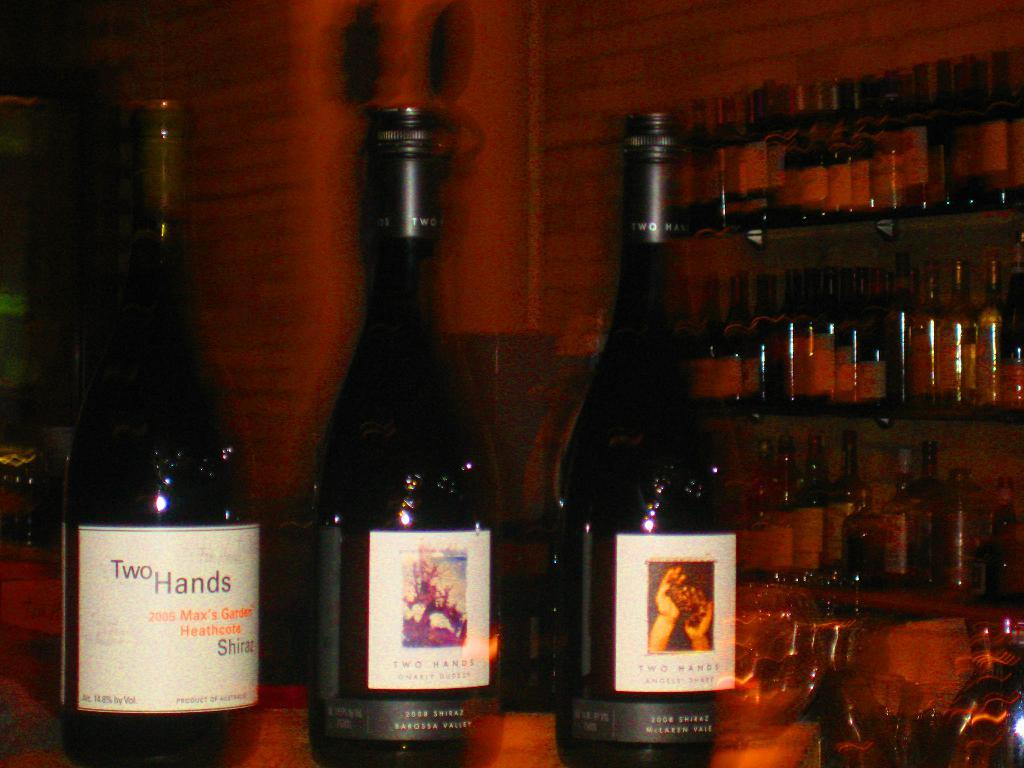<image>
Summarize the visual content of the image. A bottle of Shiraz has a Two Hands label on it. 